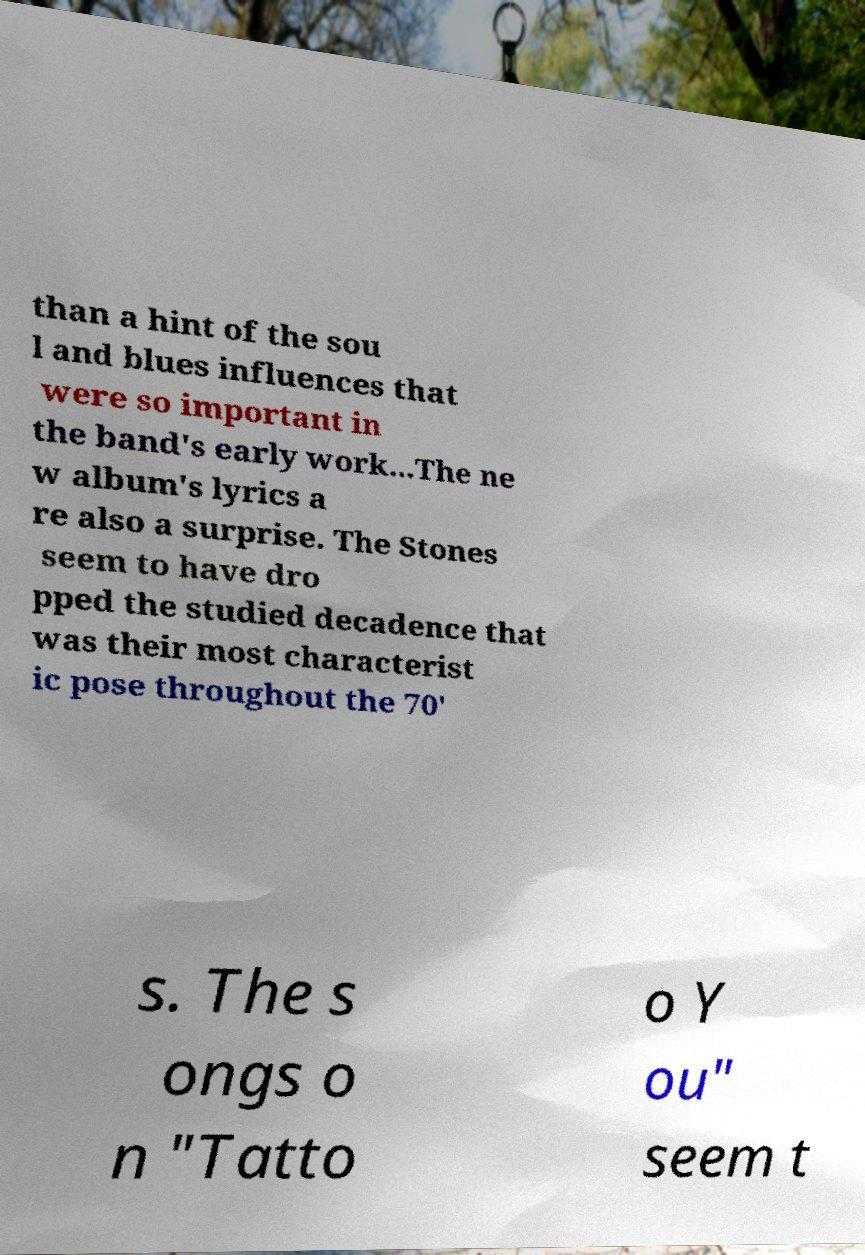Please read and relay the text visible in this image. What does it say? than a hint of the sou l and blues influences that were so important in the band's early work...The ne w album's lyrics a re also a surprise. The Stones seem to have dro pped the studied decadence that was their most characterist ic pose throughout the 70' s. The s ongs o n "Tatto o Y ou" seem t 